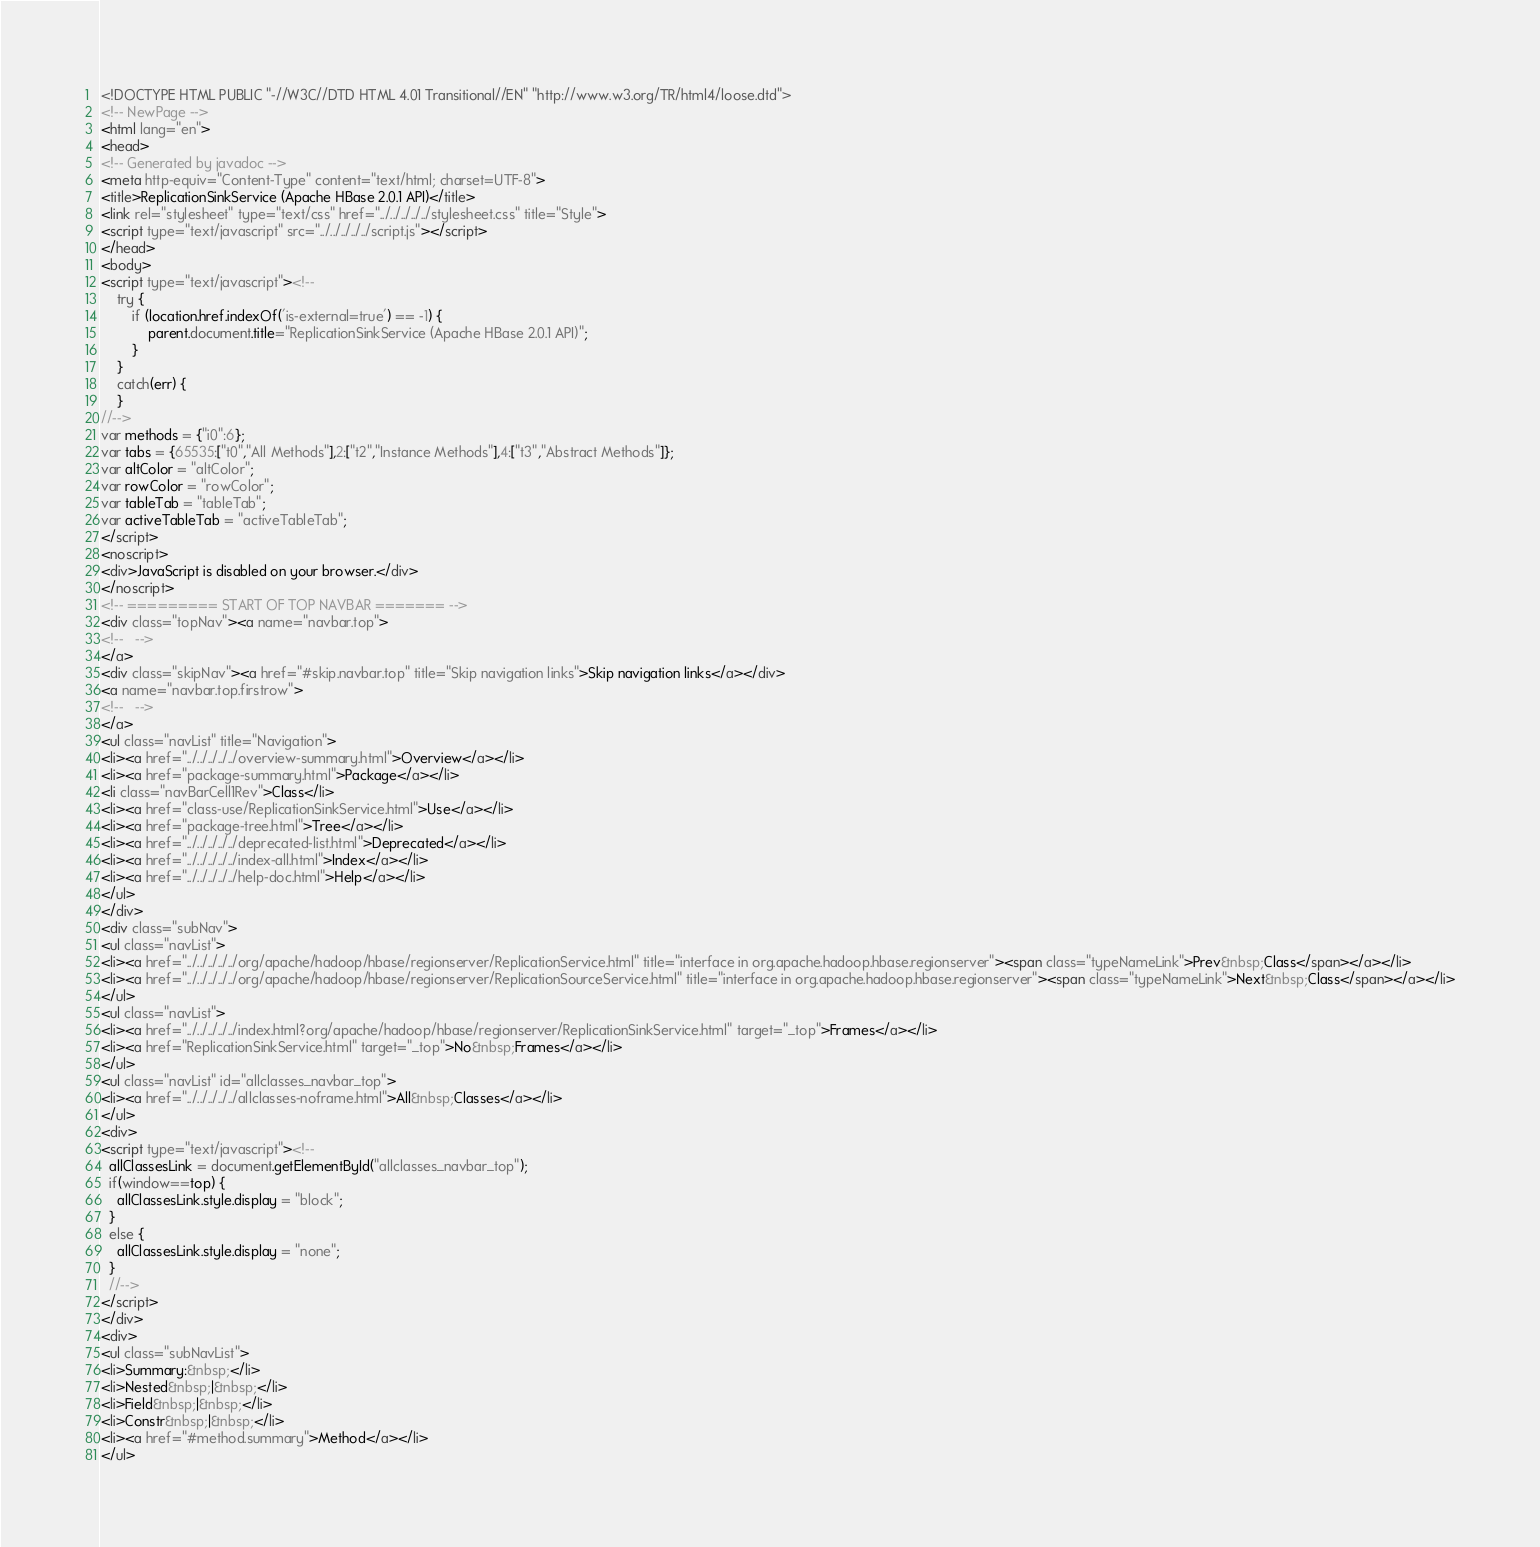<code> <loc_0><loc_0><loc_500><loc_500><_HTML_><!DOCTYPE HTML PUBLIC "-//W3C//DTD HTML 4.01 Transitional//EN" "http://www.w3.org/TR/html4/loose.dtd">
<!-- NewPage -->
<html lang="en">
<head>
<!-- Generated by javadoc -->
<meta http-equiv="Content-Type" content="text/html; charset=UTF-8">
<title>ReplicationSinkService (Apache HBase 2.0.1 API)</title>
<link rel="stylesheet" type="text/css" href="../../../../../stylesheet.css" title="Style">
<script type="text/javascript" src="../../../../../script.js"></script>
</head>
<body>
<script type="text/javascript"><!--
    try {
        if (location.href.indexOf('is-external=true') == -1) {
            parent.document.title="ReplicationSinkService (Apache HBase 2.0.1 API)";
        }
    }
    catch(err) {
    }
//-->
var methods = {"i0":6};
var tabs = {65535:["t0","All Methods"],2:["t2","Instance Methods"],4:["t3","Abstract Methods"]};
var altColor = "altColor";
var rowColor = "rowColor";
var tableTab = "tableTab";
var activeTableTab = "activeTableTab";
</script>
<noscript>
<div>JavaScript is disabled on your browser.</div>
</noscript>
<!-- ========= START OF TOP NAVBAR ======= -->
<div class="topNav"><a name="navbar.top">
<!--   -->
</a>
<div class="skipNav"><a href="#skip.navbar.top" title="Skip navigation links">Skip navigation links</a></div>
<a name="navbar.top.firstrow">
<!--   -->
</a>
<ul class="navList" title="Navigation">
<li><a href="../../../../../overview-summary.html">Overview</a></li>
<li><a href="package-summary.html">Package</a></li>
<li class="navBarCell1Rev">Class</li>
<li><a href="class-use/ReplicationSinkService.html">Use</a></li>
<li><a href="package-tree.html">Tree</a></li>
<li><a href="../../../../../deprecated-list.html">Deprecated</a></li>
<li><a href="../../../../../index-all.html">Index</a></li>
<li><a href="../../../../../help-doc.html">Help</a></li>
</ul>
</div>
<div class="subNav">
<ul class="navList">
<li><a href="../../../../../org/apache/hadoop/hbase/regionserver/ReplicationService.html" title="interface in org.apache.hadoop.hbase.regionserver"><span class="typeNameLink">Prev&nbsp;Class</span></a></li>
<li><a href="../../../../../org/apache/hadoop/hbase/regionserver/ReplicationSourceService.html" title="interface in org.apache.hadoop.hbase.regionserver"><span class="typeNameLink">Next&nbsp;Class</span></a></li>
</ul>
<ul class="navList">
<li><a href="../../../../../index.html?org/apache/hadoop/hbase/regionserver/ReplicationSinkService.html" target="_top">Frames</a></li>
<li><a href="ReplicationSinkService.html" target="_top">No&nbsp;Frames</a></li>
</ul>
<ul class="navList" id="allclasses_navbar_top">
<li><a href="../../../../../allclasses-noframe.html">All&nbsp;Classes</a></li>
</ul>
<div>
<script type="text/javascript"><!--
  allClassesLink = document.getElementById("allclasses_navbar_top");
  if(window==top) {
    allClassesLink.style.display = "block";
  }
  else {
    allClassesLink.style.display = "none";
  }
  //-->
</script>
</div>
<div>
<ul class="subNavList">
<li>Summary:&nbsp;</li>
<li>Nested&nbsp;|&nbsp;</li>
<li>Field&nbsp;|&nbsp;</li>
<li>Constr&nbsp;|&nbsp;</li>
<li><a href="#method.summary">Method</a></li>
</ul></code> 